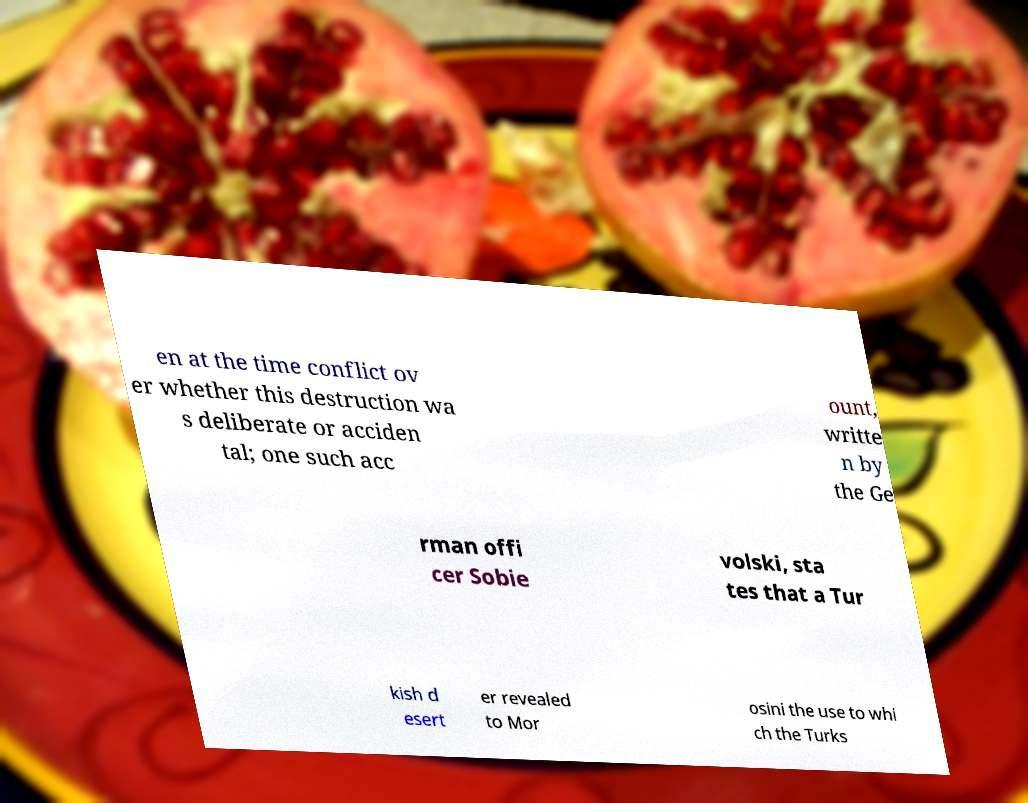Could you assist in decoding the text presented in this image and type it out clearly? en at the time conflict ov er whether this destruction wa s deliberate or acciden tal; one such acc ount, writte n by the Ge rman offi cer Sobie volski, sta tes that a Tur kish d esert er revealed to Mor osini the use to whi ch the Turks 